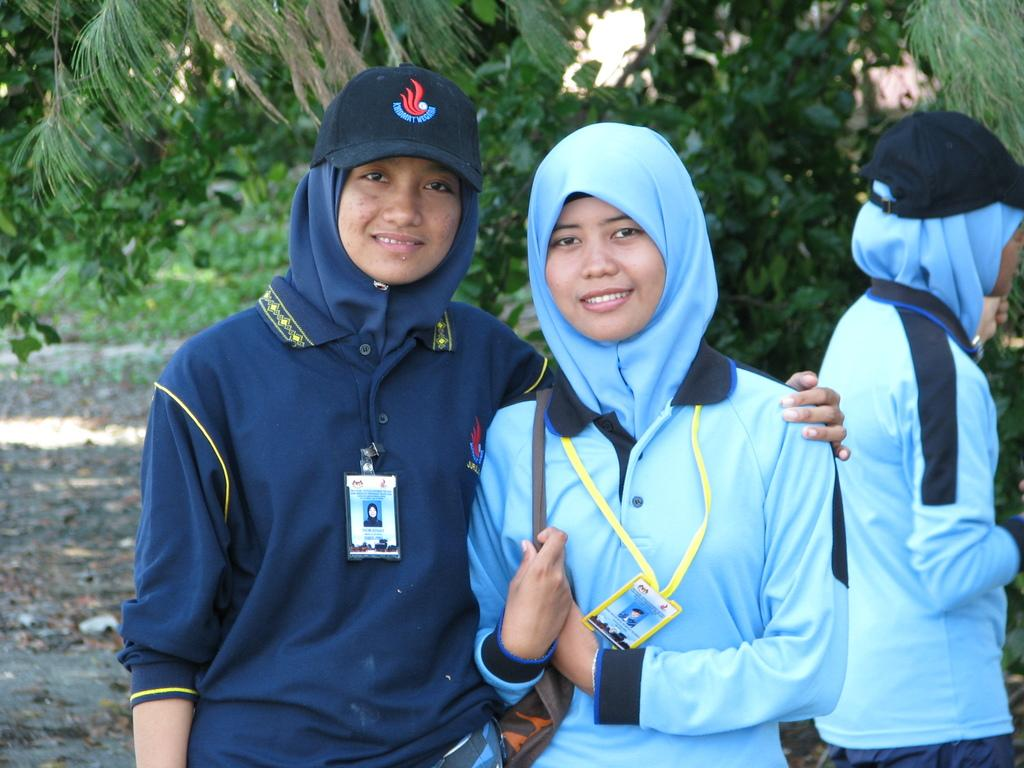What is the main subject of the image? The main subject of the image is a group of people. Can you describe any distinguishing features of the people in the group? Some people in the group are wearing badges. What can be seen in the background of the image? There are trees visible in the background of the image. What type of night activity is the group participating in? The image does not indicate that the group is participating in any night activity, as there is no information about the time of day or the specific activity they are engaged in. 